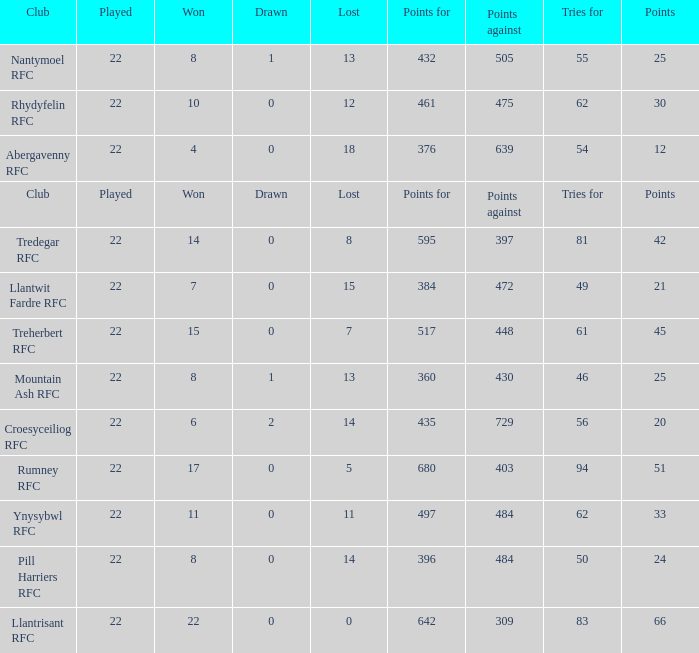How many points for were scored by the team that won exactly 22? 642.0. Give me the full table as a dictionary. {'header': ['Club', 'Played', 'Won', 'Drawn', 'Lost', 'Points for', 'Points against', 'Tries for', 'Points'], 'rows': [['Nantymoel RFC', '22', '8', '1', '13', '432', '505', '55', '25'], ['Rhydyfelin RFC', '22', '10', '0', '12', '461', '475', '62', '30'], ['Abergavenny RFC', '22', '4', '0', '18', '376', '639', '54', '12'], ['Club', 'Played', 'Won', 'Drawn', 'Lost', 'Points for', 'Points against', 'Tries for', 'Points'], ['Tredegar RFC', '22', '14', '0', '8', '595', '397', '81', '42'], ['Llantwit Fardre RFC', '22', '7', '0', '15', '384', '472', '49', '21'], ['Treherbert RFC', '22', '15', '0', '7', '517', '448', '61', '45'], ['Mountain Ash RFC', '22', '8', '1', '13', '360', '430', '46', '25'], ['Croesyceiliog RFC', '22', '6', '2', '14', '435', '729', '56', '20'], ['Rumney RFC', '22', '17', '0', '5', '680', '403', '94', '51'], ['Ynysybwl RFC', '22', '11', '0', '11', '497', '484', '62', '33'], ['Pill Harriers RFC', '22', '8', '0', '14', '396', '484', '50', '24'], ['Llantrisant RFC', '22', '22', '0', '0', '642', '309', '83', '66']]} 